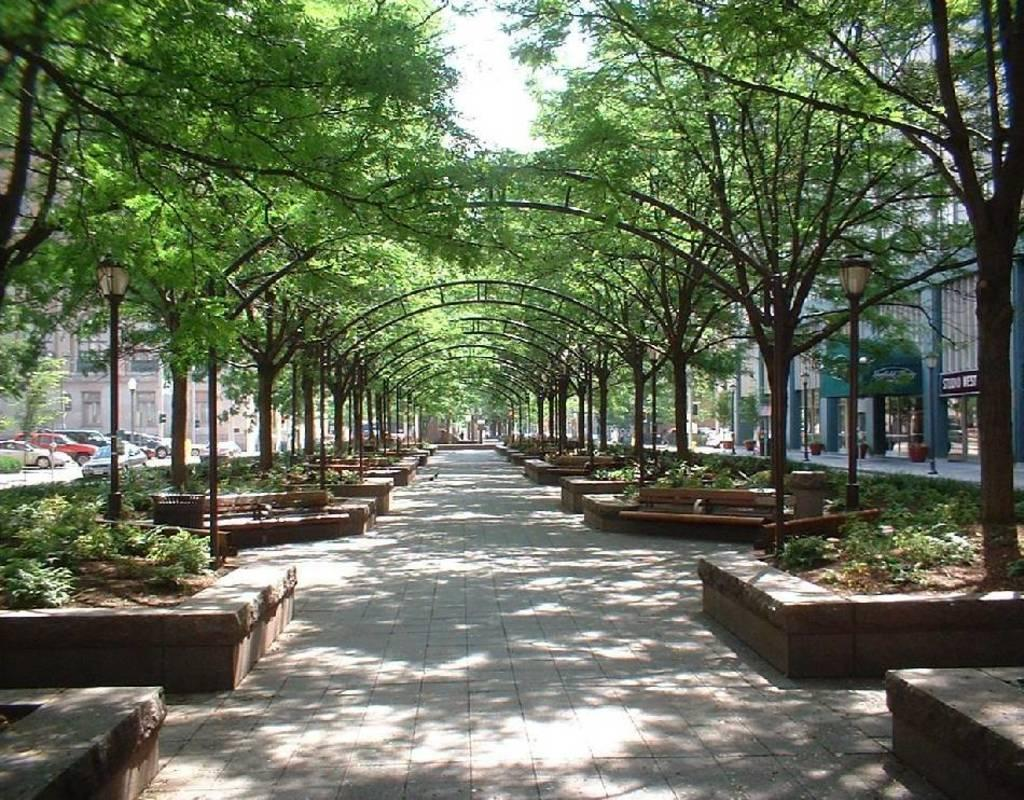What can be seen running through the center of the image? There is a path in the image. What type of vegetation is present alongside the path? Trees are present on either side of the path. What structures are visible on either side of the path? Iron arches are visible on either side of the path. What might provide illumination along the path at night? Light poles are present on either side of the path. What type of vehicles can be seen in the image? Cars are on the road in the image. What type of man-made structures are visible in the image? There are buildings in the image. What type of advertisement can be seen hanging from the trees along the path? There is no advertisement present in the image; only trees, iron arches, light poles, cars, and buildings are visible. 